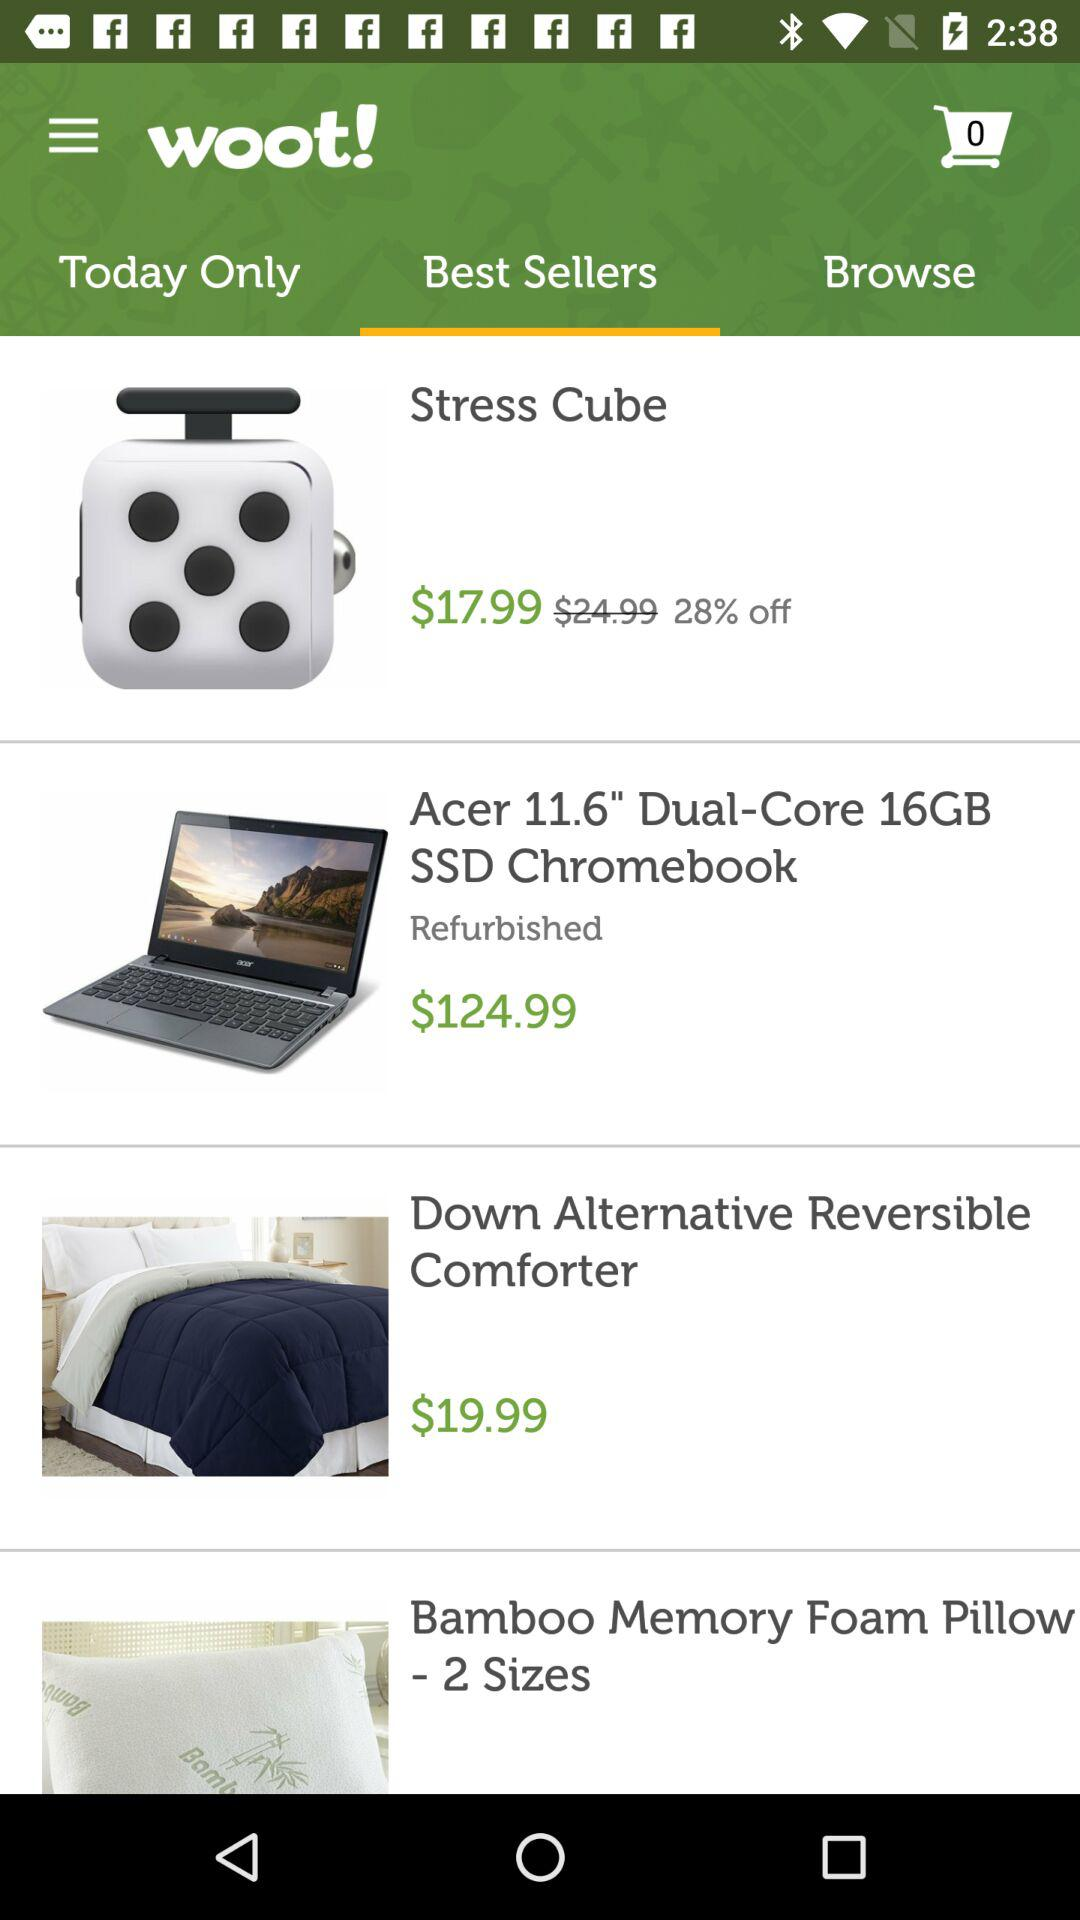What is the discounted price of the "Stress Cube"? The discounted price is $17.99. 